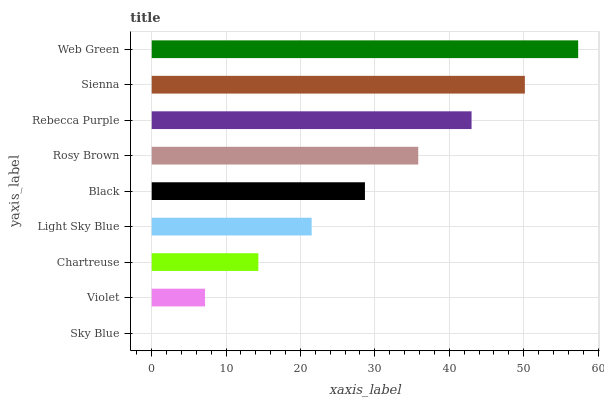Is Sky Blue the minimum?
Answer yes or no. Yes. Is Web Green the maximum?
Answer yes or no. Yes. Is Violet the minimum?
Answer yes or no. No. Is Violet the maximum?
Answer yes or no. No. Is Violet greater than Sky Blue?
Answer yes or no. Yes. Is Sky Blue less than Violet?
Answer yes or no. Yes. Is Sky Blue greater than Violet?
Answer yes or no. No. Is Violet less than Sky Blue?
Answer yes or no. No. Is Black the high median?
Answer yes or no. Yes. Is Black the low median?
Answer yes or no. Yes. Is Rosy Brown the high median?
Answer yes or no. No. Is Sienna the low median?
Answer yes or no. No. 